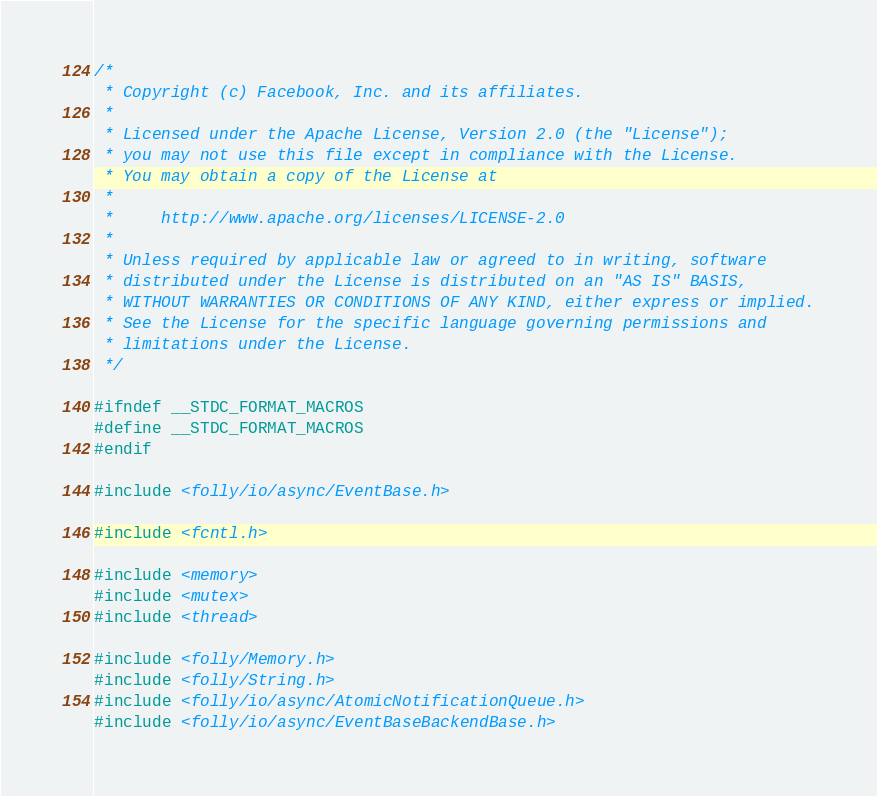Convert code to text. <code><loc_0><loc_0><loc_500><loc_500><_C++_>/*
 * Copyright (c) Facebook, Inc. and its affiliates.
 *
 * Licensed under the Apache License, Version 2.0 (the "License");
 * you may not use this file except in compliance with the License.
 * You may obtain a copy of the License at
 *
 *     http://www.apache.org/licenses/LICENSE-2.0
 *
 * Unless required by applicable law or agreed to in writing, software
 * distributed under the License is distributed on an "AS IS" BASIS,
 * WITHOUT WARRANTIES OR CONDITIONS OF ANY KIND, either express or implied.
 * See the License for the specific language governing permissions and
 * limitations under the License.
 */

#ifndef __STDC_FORMAT_MACROS
#define __STDC_FORMAT_MACROS
#endif

#include <folly/io/async/EventBase.h>

#include <fcntl.h>

#include <memory>
#include <mutex>
#include <thread>

#include <folly/Memory.h>
#include <folly/String.h>
#include <folly/io/async/AtomicNotificationQueue.h>
#include <folly/io/async/EventBaseBackendBase.h></code> 